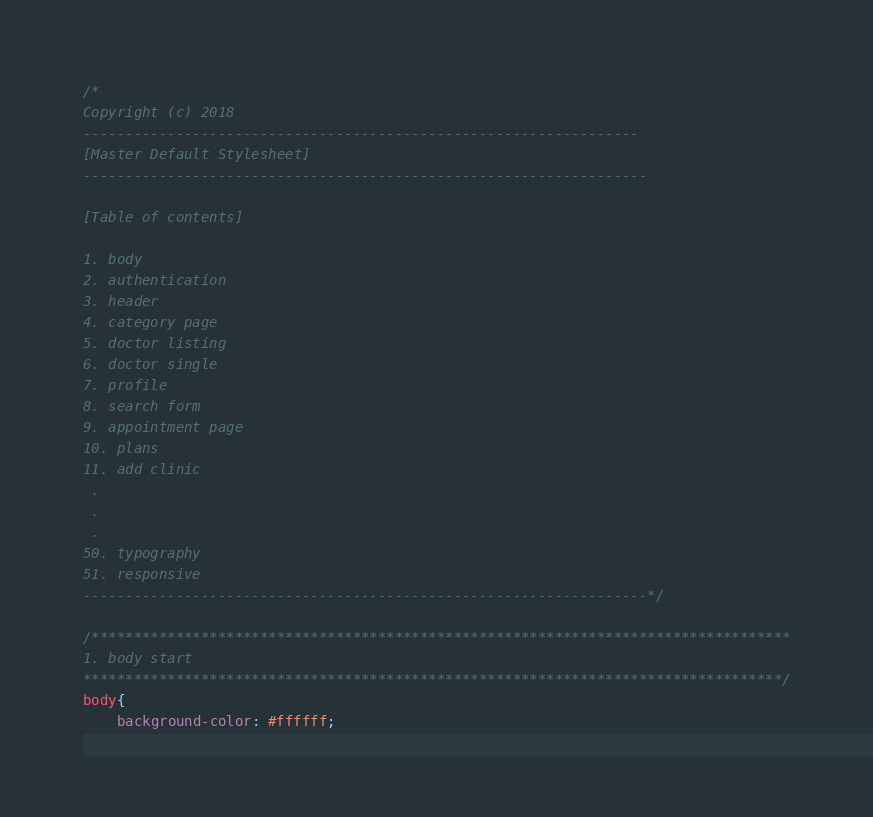<code> <loc_0><loc_0><loc_500><loc_500><_CSS_>/*
Copyright (c) 2018
------------------------------------------------------------------
[Master Default Stylesheet]
-------------------------------------------------------------------

[Table of contents]

1. body
2. authentication
3. header
4. category page
5. doctor listing
6. doctor single
7. profile
8. search form
9. appointment page
10. plans
11. add clinic
 .
 .
 .
50. typography
51. responsive
-------------------------------------------------------------------*/

/***********************************************************************************
1. body start
***********************************************************************************/
body{
    background-color: #ffffff;	</code> 